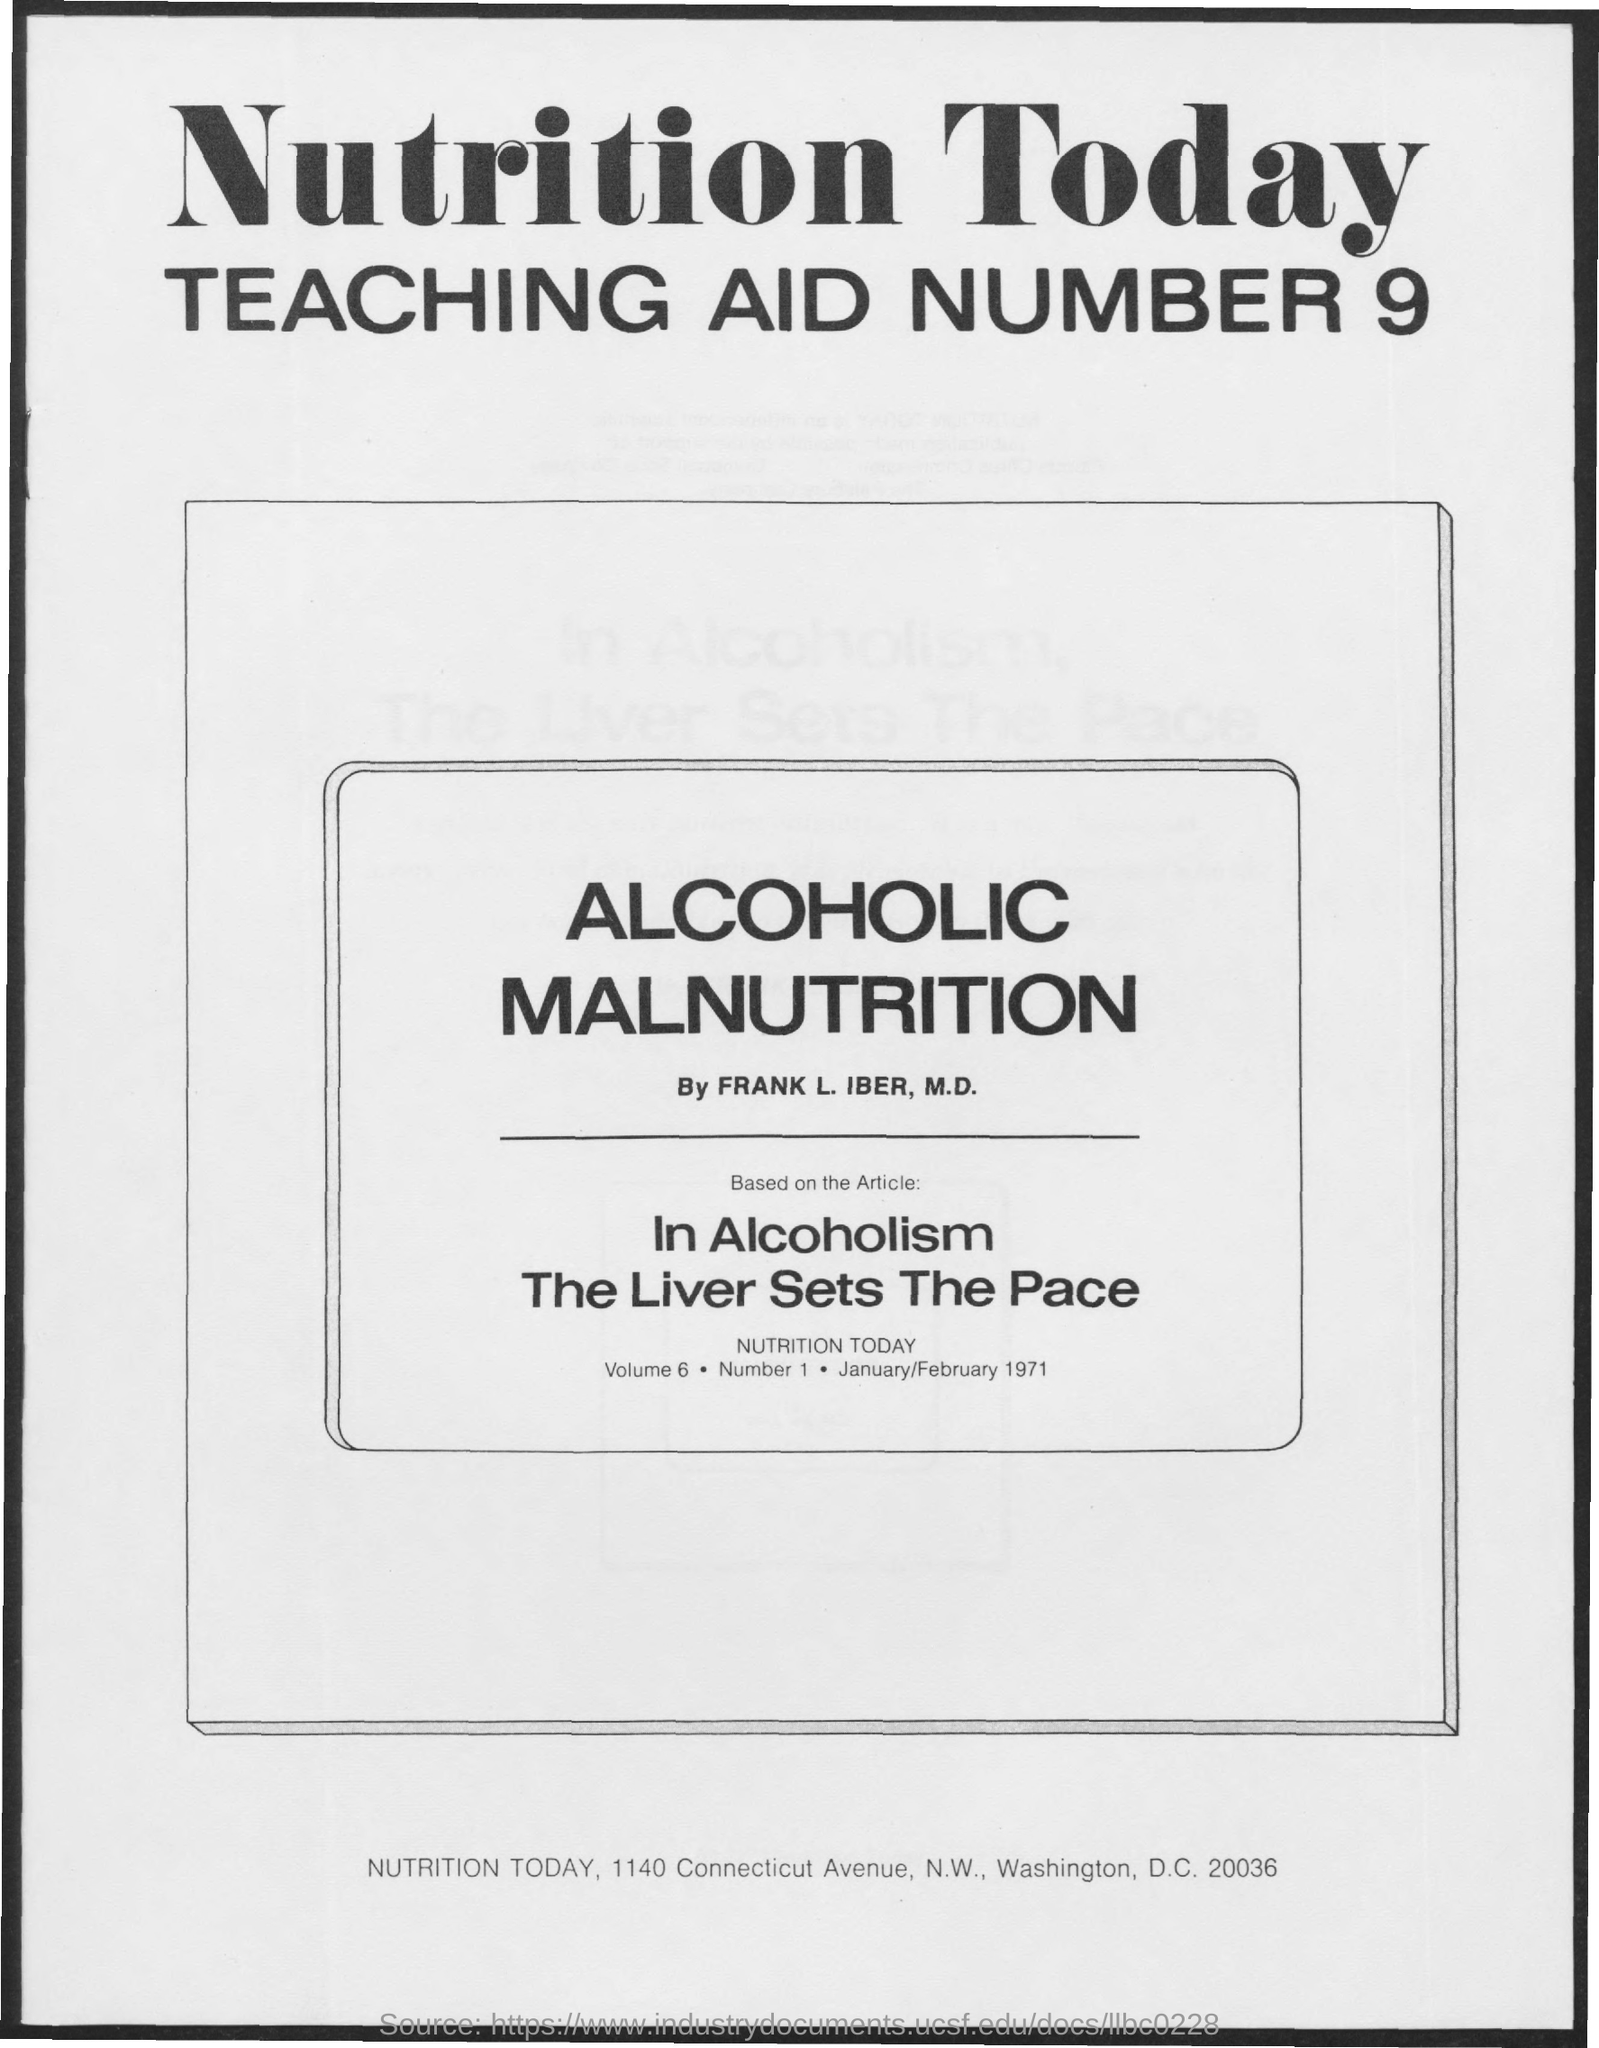What is the Volume?
Provide a succinct answer. 6. What is the Number?
Your response must be concise. 1. What is the date on the document?
Offer a terse response. JANUARY/FEBRUARY 1971. 